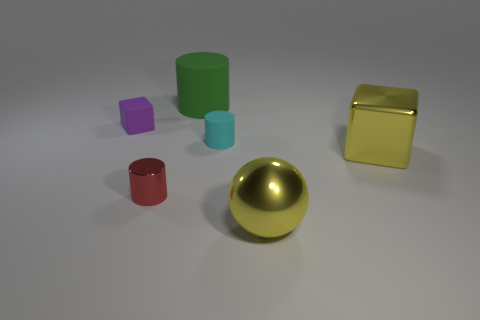Is the number of purple matte things left of the yellow block the same as the number of small matte cylinders?
Offer a very short reply. Yes. What number of gray things have the same material as the cyan cylinder?
Ensure brevity in your answer.  0. Are there fewer small cyan rubber things than brown cylinders?
Provide a short and direct response. No. Do the big metallic block right of the cyan matte object and the small block have the same color?
Ensure brevity in your answer.  No. There is a yellow metallic object that is in front of the cube that is on the right side of the large green matte cylinder; how many metal cylinders are behind it?
Your answer should be very brief. 1. There is a big metal ball; what number of red cylinders are in front of it?
Your answer should be very brief. 0. There is another big matte thing that is the same shape as the cyan matte thing; what color is it?
Offer a very short reply. Green. What is the material of the cylinder that is in front of the purple object and right of the red object?
Provide a succinct answer. Rubber. There is a rubber cylinder in front of the green rubber thing; does it have the same size as the small metal object?
Your response must be concise. Yes. What is the big ball made of?
Your response must be concise. Metal. 